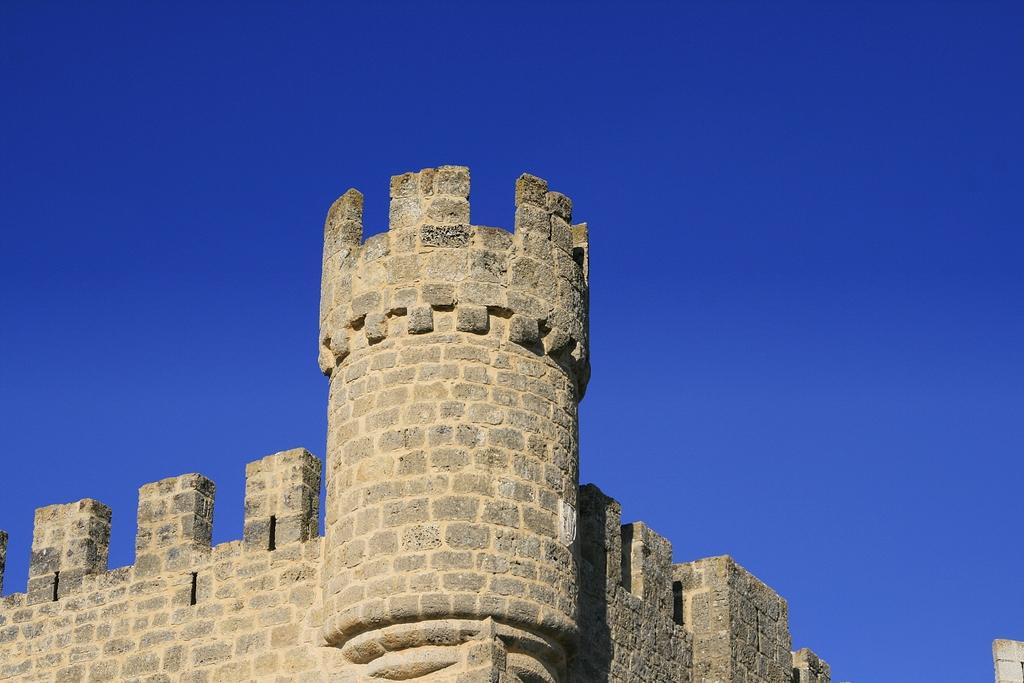What type of structure is present in the image? There is a fort in the image. What material is used to construct the walls of the fort? The walls of the fort are made up of rocks. What can be seen in the background of the image? The sky is visible in the image, and it is blue in color. Where is the faucet located in the image? There is no faucet present in the image. What word is written on the walls of the fort? The image does not show any words written on the walls of the fort. 